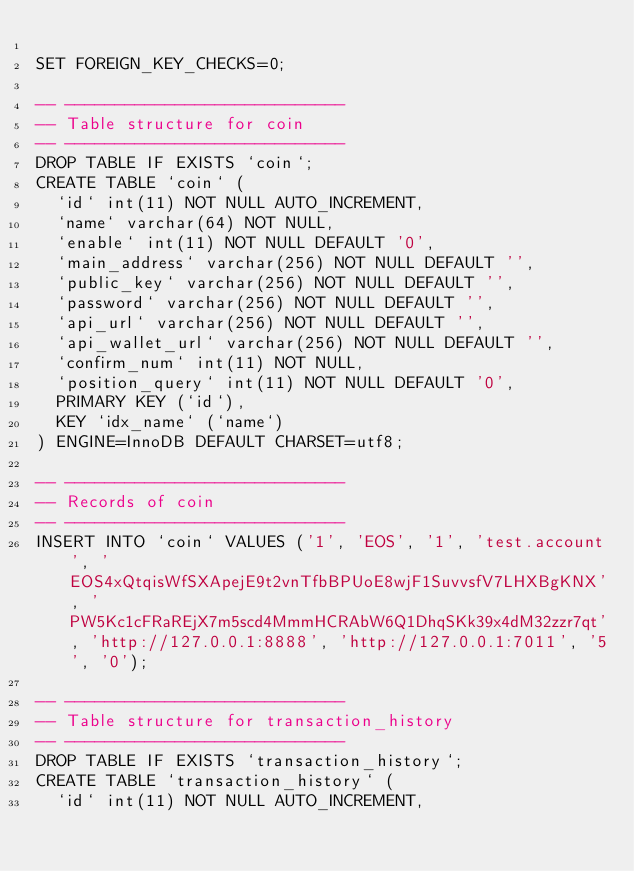<code> <loc_0><loc_0><loc_500><loc_500><_SQL_>
SET FOREIGN_KEY_CHECKS=0;

-- ----------------------------
-- Table structure for coin
-- ----------------------------
DROP TABLE IF EXISTS `coin`;
CREATE TABLE `coin` (
  `id` int(11) NOT NULL AUTO_INCREMENT,
  `name` varchar(64) NOT NULL,
  `enable` int(11) NOT NULL DEFAULT '0',
  `main_address` varchar(256) NOT NULL DEFAULT '',
  `public_key` varchar(256) NOT NULL DEFAULT '',
  `password` varchar(256) NOT NULL DEFAULT '',
  `api_url` varchar(256) NOT NULL DEFAULT '',
  `api_wallet_url` varchar(256) NOT NULL DEFAULT '',
  `confirm_num` int(11) NOT NULL,
  `position_query` int(11) NOT NULL DEFAULT '0',
  PRIMARY KEY (`id`),
  KEY `idx_name` (`name`)
) ENGINE=InnoDB DEFAULT CHARSET=utf8;

-- ----------------------------
-- Records of coin
-- ----------------------------
INSERT INTO `coin` VALUES ('1', 'EOS', '1', 'test.account', 'EOS4xQtqisWfSXApejE9t2vnTfbBPUoE8wjF1SuvvsfV7LHXBgKNX', 'PW5Kc1cFRaREjX7m5scd4MmmHCRAbW6Q1DhqSKk39x4dM32zzr7qt', 'http://127.0.0.1:8888', 'http://127.0.0.1:7011', '5', '0');

-- ----------------------------
-- Table structure for transaction_history
-- ----------------------------
DROP TABLE IF EXISTS `transaction_history`;
CREATE TABLE `transaction_history` (
  `id` int(11) NOT NULL AUTO_INCREMENT,</code> 